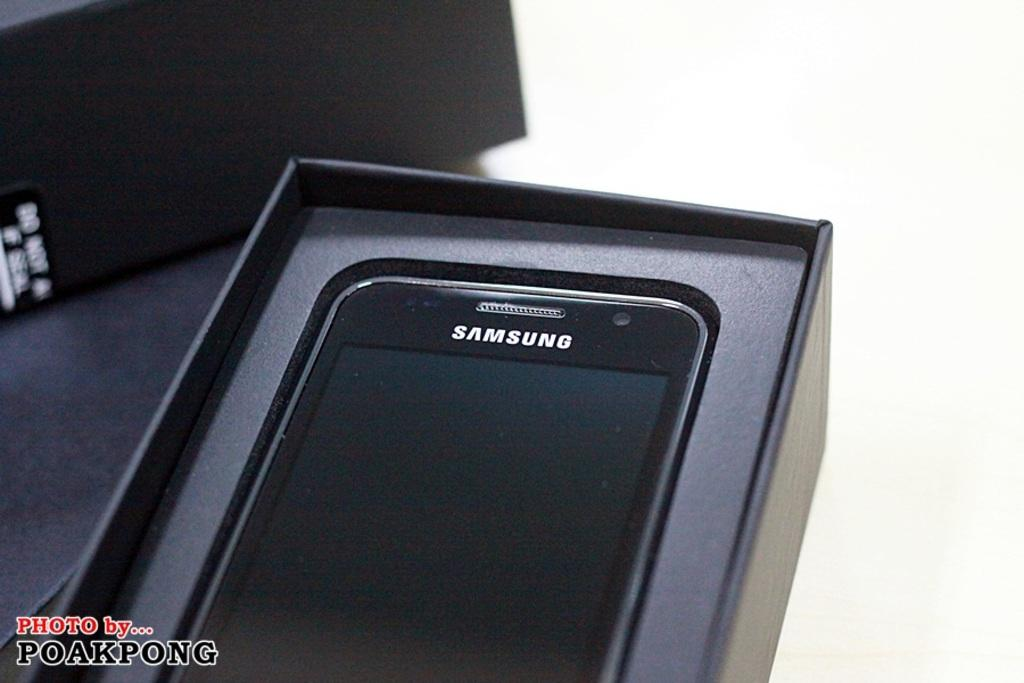<image>
Create a compact narrative representing the image presented. A black cell phone with the Samsung on it in a black box. 